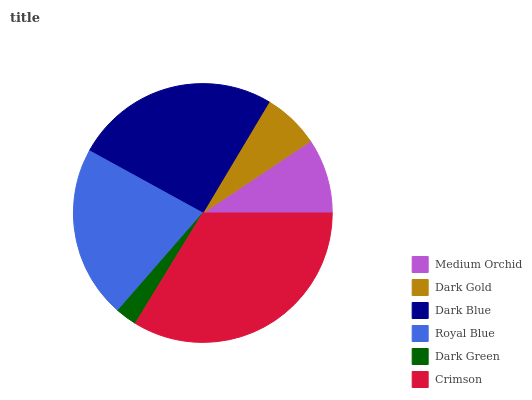Is Dark Green the minimum?
Answer yes or no. Yes. Is Crimson the maximum?
Answer yes or no. Yes. Is Dark Gold the minimum?
Answer yes or no. No. Is Dark Gold the maximum?
Answer yes or no. No. Is Medium Orchid greater than Dark Gold?
Answer yes or no. Yes. Is Dark Gold less than Medium Orchid?
Answer yes or no. Yes. Is Dark Gold greater than Medium Orchid?
Answer yes or no. No. Is Medium Orchid less than Dark Gold?
Answer yes or no. No. Is Royal Blue the high median?
Answer yes or no. Yes. Is Medium Orchid the low median?
Answer yes or no. Yes. Is Dark Gold the high median?
Answer yes or no. No. Is Crimson the low median?
Answer yes or no. No. 